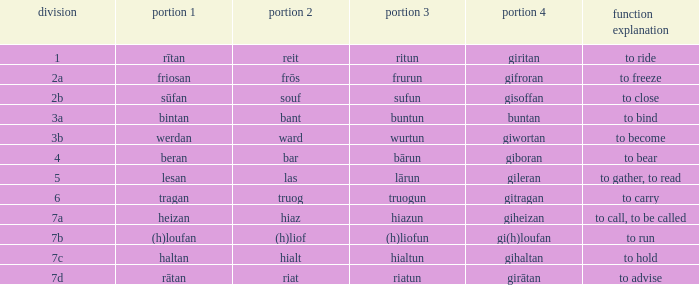What is the verb meaning of the word with part 3 "sufun"? To close. 